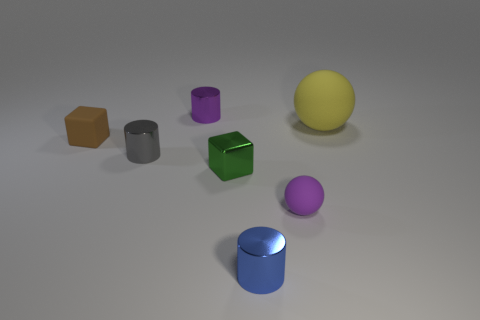If I were to stack some of these objects, which ones would make a stable tower and why? To make a stable tower, you could start with the green hexahedron as it has a flat surface for a base. Next, you could place the gray cylinder on it, followed by the pink sphere on top. The flat surfaces of the hexahedron and cylinder would provide stability, whereas the sphere would balance at the peak due to the progressive reduction in size of each object. 